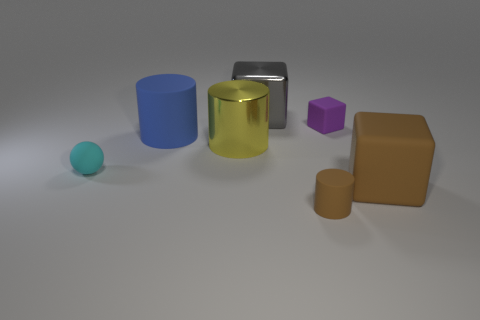What is the shape of the matte thing that is the same color as the tiny matte cylinder?
Your answer should be compact. Cube. Do the cyan rubber sphere and the purple rubber object have the same size?
Offer a very short reply. Yes. The cube that is left of the purple cube is what color?
Keep it short and to the point. Gray. There is a thing that is made of the same material as the yellow cylinder; what size is it?
Provide a short and direct response. Large. There is a cyan matte thing; does it have the same size as the cylinder that is right of the big gray metal thing?
Give a very brief answer. Yes. There is a large block that is in front of the yellow cylinder; what material is it?
Give a very brief answer. Rubber. What number of objects are behind the cyan rubber ball on the left side of the large brown thing?
Ensure brevity in your answer.  4. Is there a yellow object that has the same shape as the cyan matte object?
Your response must be concise. No. Is the size of the object behind the tiny block the same as the cube that is in front of the big matte cylinder?
Offer a very short reply. Yes. What is the shape of the large object behind the large cylinder that is behind the metal cylinder?
Provide a succinct answer. Cube. 